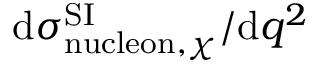Convert formula to latex. <formula><loc_0><loc_0><loc_500><loc_500>d \sigma _ { n u c l e o n , \chi } ^ { S I } / d q ^ { 2 }</formula> 